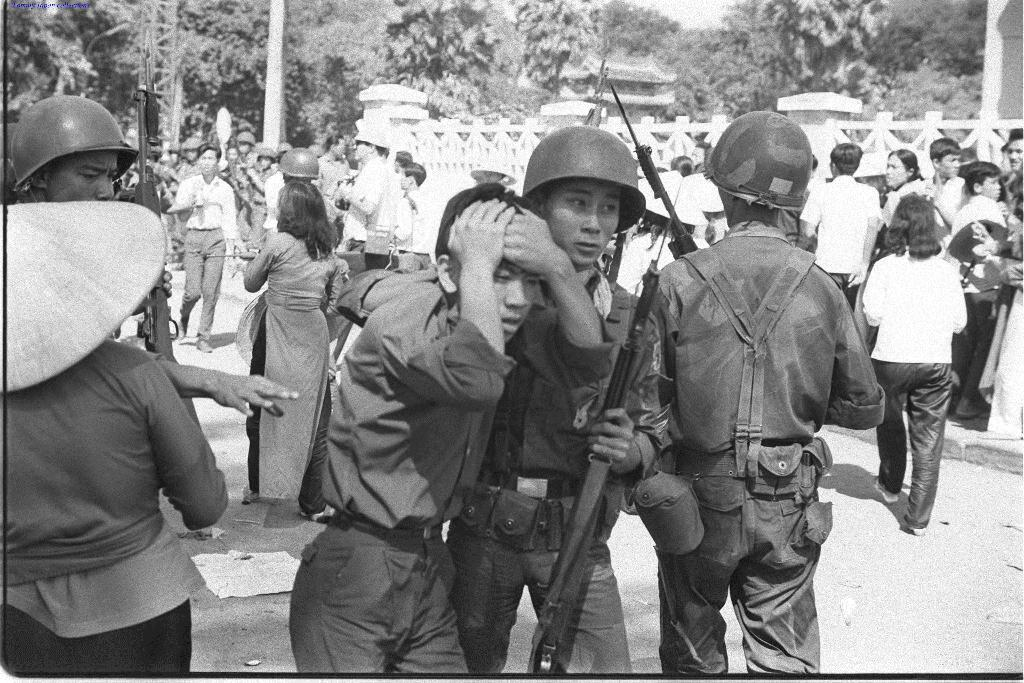What is the color scheme of the image? The image is black and white. What can be seen in the background of the image? There are trees in the background of the image. Who or what is present in the image? There are people in the image. What are some people in the image wearing? Some people in the image are wearing helmets. What are some people in the image holding? Some people in the image are holding guns. What type of iron is being used by the team in the image? There is no iron present in the image, and no team is mentioned. 